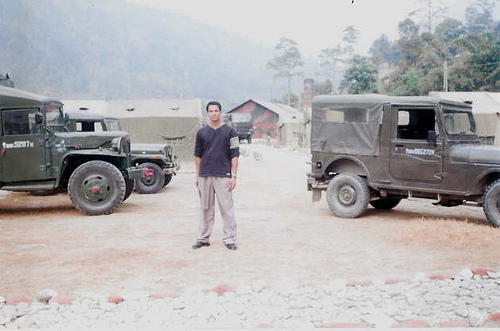What can be inferred about the location from the background? The image indicates a relatively remote environment with a mountainous background and sparse vegetation. The small structure in the background with a sloped roof could imply a rural setting or a temporary encampment, possibly for military use given the context provided by the vehicles. 